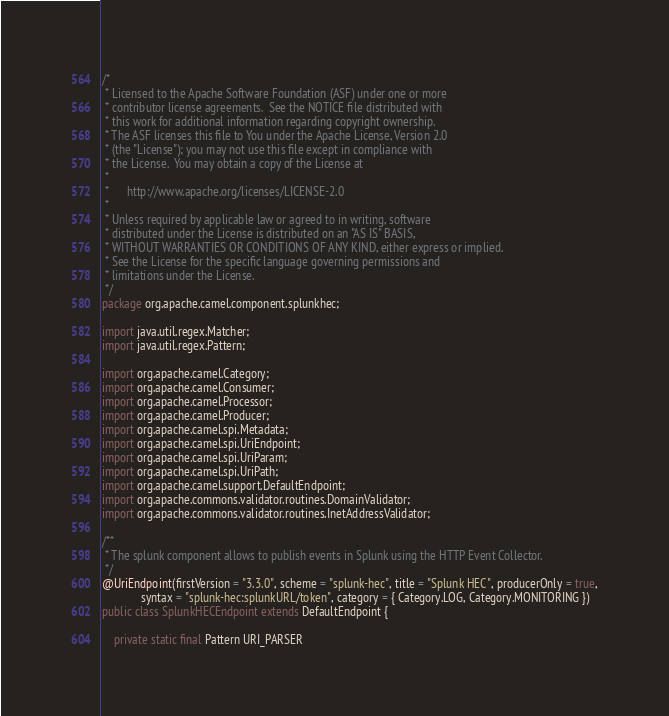Convert code to text. <code><loc_0><loc_0><loc_500><loc_500><_Java_>/*
 * Licensed to the Apache Software Foundation (ASF) under one or more
 * contributor license agreements.  See the NOTICE file distributed with
 * this work for additional information regarding copyright ownership.
 * The ASF licenses this file to You under the Apache License, Version 2.0
 * (the "License"); you may not use this file except in compliance with
 * the License.  You may obtain a copy of the License at
 *
 *      http://www.apache.org/licenses/LICENSE-2.0
 *
 * Unless required by applicable law or agreed to in writing, software
 * distributed under the License is distributed on an "AS IS" BASIS,
 * WITHOUT WARRANTIES OR CONDITIONS OF ANY KIND, either express or implied.
 * See the License for the specific language governing permissions and
 * limitations under the License.
 */
package org.apache.camel.component.splunkhec;

import java.util.regex.Matcher;
import java.util.regex.Pattern;

import org.apache.camel.Category;
import org.apache.camel.Consumer;
import org.apache.camel.Processor;
import org.apache.camel.Producer;
import org.apache.camel.spi.Metadata;
import org.apache.camel.spi.UriEndpoint;
import org.apache.camel.spi.UriParam;
import org.apache.camel.spi.UriPath;
import org.apache.camel.support.DefaultEndpoint;
import org.apache.commons.validator.routines.DomainValidator;
import org.apache.commons.validator.routines.InetAddressValidator;

/**
 * The splunk component allows to publish events in Splunk using the HTTP Event Collector.
 */
@UriEndpoint(firstVersion = "3.3.0", scheme = "splunk-hec", title = "Splunk HEC", producerOnly = true,
             syntax = "splunk-hec:splunkURL/token", category = { Category.LOG, Category.MONITORING })
public class SplunkHECEndpoint extends DefaultEndpoint {

    private static final Pattern URI_PARSER</code> 